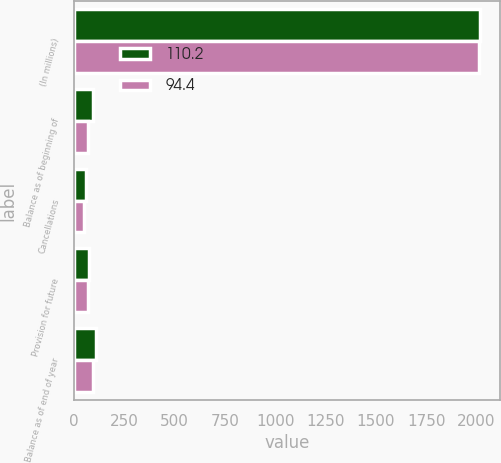Convert chart. <chart><loc_0><loc_0><loc_500><loc_500><stacked_bar_chart><ecel><fcel>(In millions)<fcel>Balance as of beginning of<fcel>Cancellations<fcel>Provision for future<fcel>Balance as of end of year<nl><fcel>110.2<fcel>2016<fcel>94.4<fcel>61.3<fcel>77.1<fcel>110.2<nl><fcel>94.4<fcel>2015<fcel>72.5<fcel>49.1<fcel>71<fcel>94.4<nl></chart> 